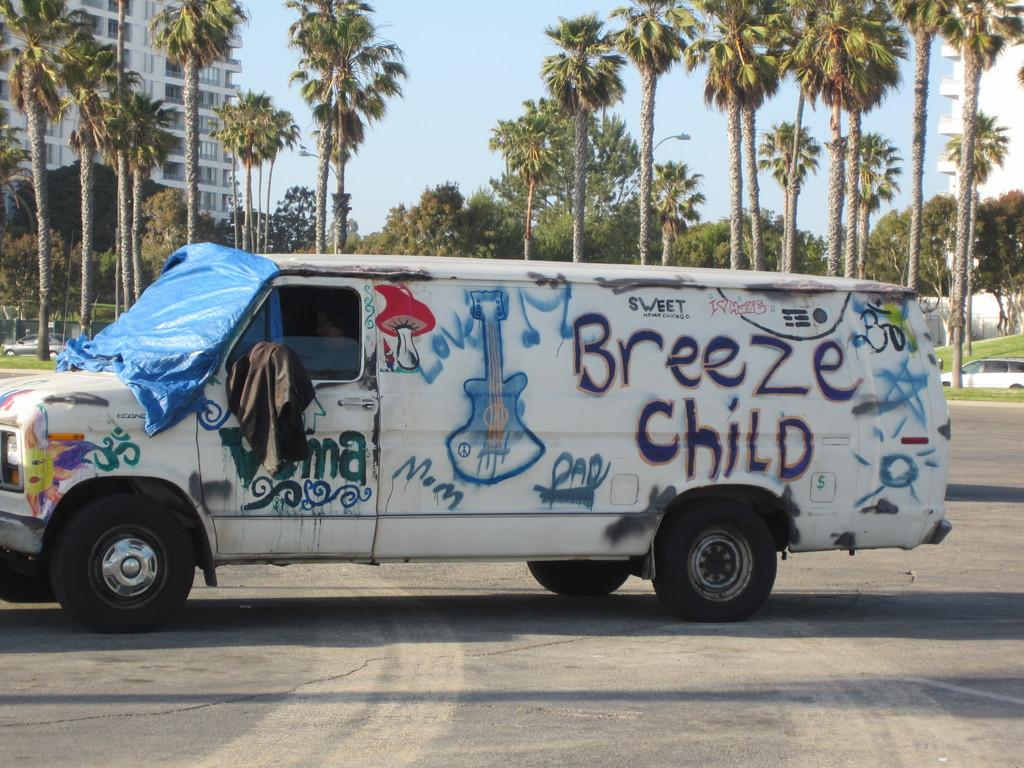What is on the road in the image? There is a vehicle on the road in the image. What type of natural elements can be seen in the image? Trees are visible in the image. What type of man-made structures are present in the image? Buildings are present in the image. What is visible in the background of the image? The sky is visible in the background of the image. What type of polish is being applied to the car in the image? There is no indication in the image that any polish is being applied to the car. 